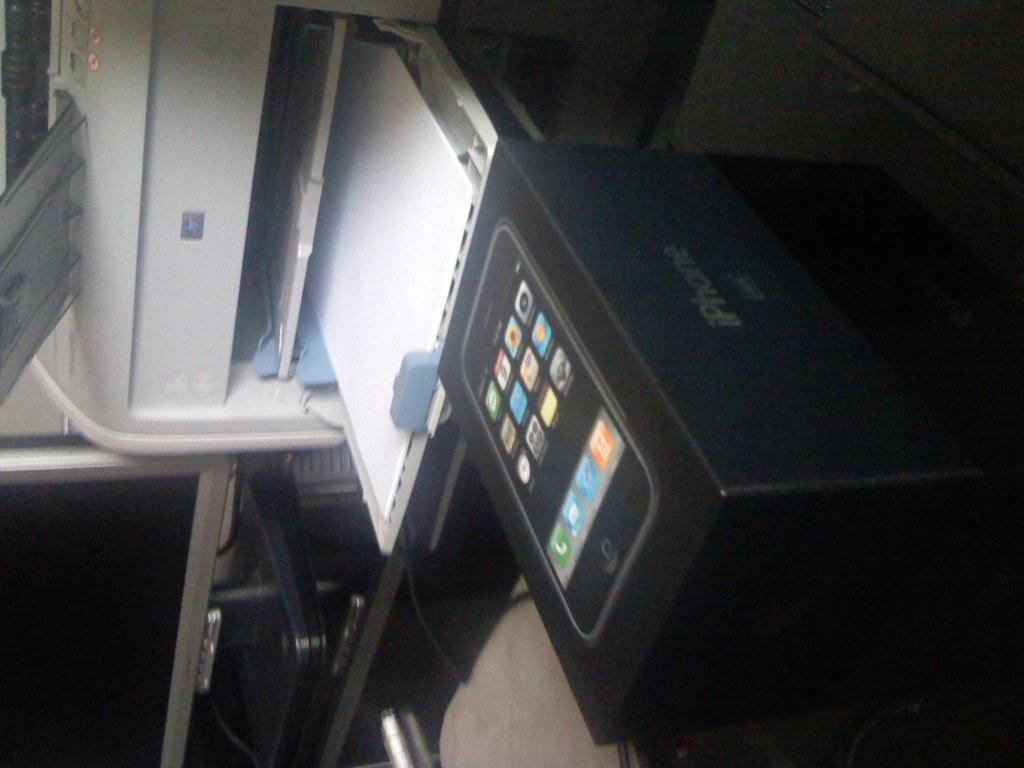<image>
Relay a brief, clear account of the picture shown. A Iphone box that is in front of a printer. 